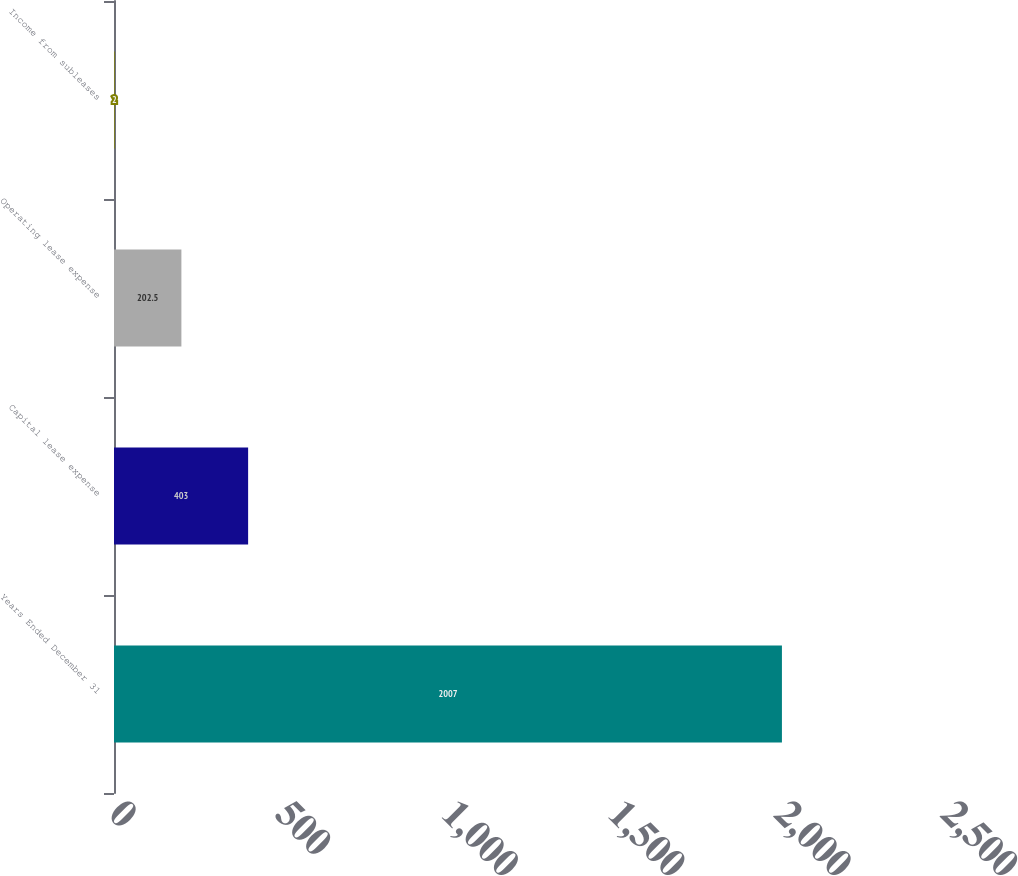<chart> <loc_0><loc_0><loc_500><loc_500><bar_chart><fcel>Years Ended December 31<fcel>Capital lease expense<fcel>Operating lease expense<fcel>Income from subleases<nl><fcel>2007<fcel>403<fcel>202.5<fcel>2<nl></chart> 